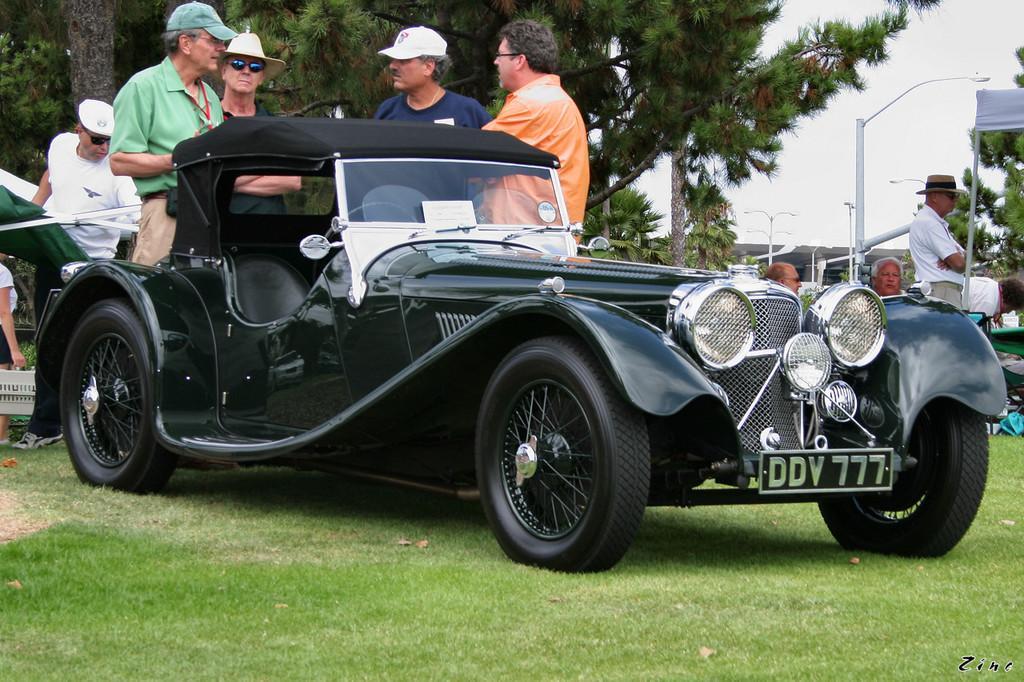In one or two sentences, can you explain what this image depicts? In this image there is a car on a ground, in the background there are people standing, few are sitting and there are trees, poles. 